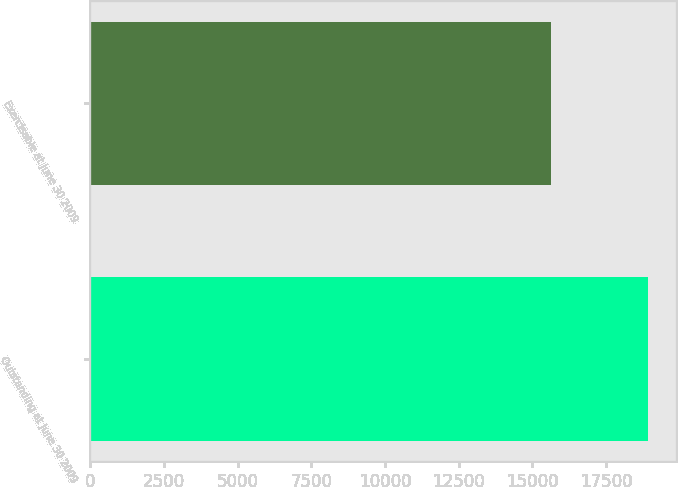Convert chart to OTSL. <chart><loc_0><loc_0><loc_500><loc_500><bar_chart><fcel>Outstanding at June 30 2009<fcel>Exercisable at June 30 2009<nl><fcel>18914.7<fcel>15647<nl></chart> 